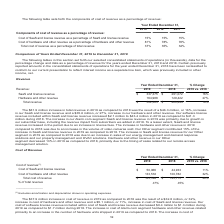According to Alarmcom Holdings's financial document, What was the Cost of SaaS and license revenue in 2019? According to the financial document, $50,066 (in thousands). The relevant text states: "revenue (1) : Cost of SaaS and license revenue $ 50,066 $ 44,933 11% Cost of hardware and other revenue 133,533 100,782 32% Total cost of revenue $ 183,599..." Also, What was the Cost of hardware and other revenue in 2018? According to the financial document, 100,782 (in thousands). The relevant text states: "33 11% Cost of hardware and other revenue 133,533 100,782 32% Total cost of revenue $ 183,599 $ 145,715 26% % of total revenue 37% 35%..." Also, What was the total cost of revenue in 2018? According to the financial document, $145,715 (in thousands). The relevant text states: "533 100,782 32% Total cost of revenue $ 183,599 $ 145,715 26% % of total revenue 37% 35%..." Also, How many years did total cost of revenue exceed $150,000 thousand? Based on the analysis, there are 1 instances. The counting process: 2019. Also, How many costs of revenue exceeded $100,000 thousand in 2019? Based on the analysis, there are 1 instances. The counting process: Cost of hardware and other revenue. Also, can you calculate: What was the change in total cost of revenue as a percentage of total revenue between 2018 and 2019? Based on the calculation: 37-35, the result is 2 (percentage). This is based on the information: "evenue $ 183,599 $ 145,715 26% % of total revenue 37% 35% ue $ 183,599 $ 145,715 26% % of total revenue 37% 35%..." The key data points involved are: 35, 37. 